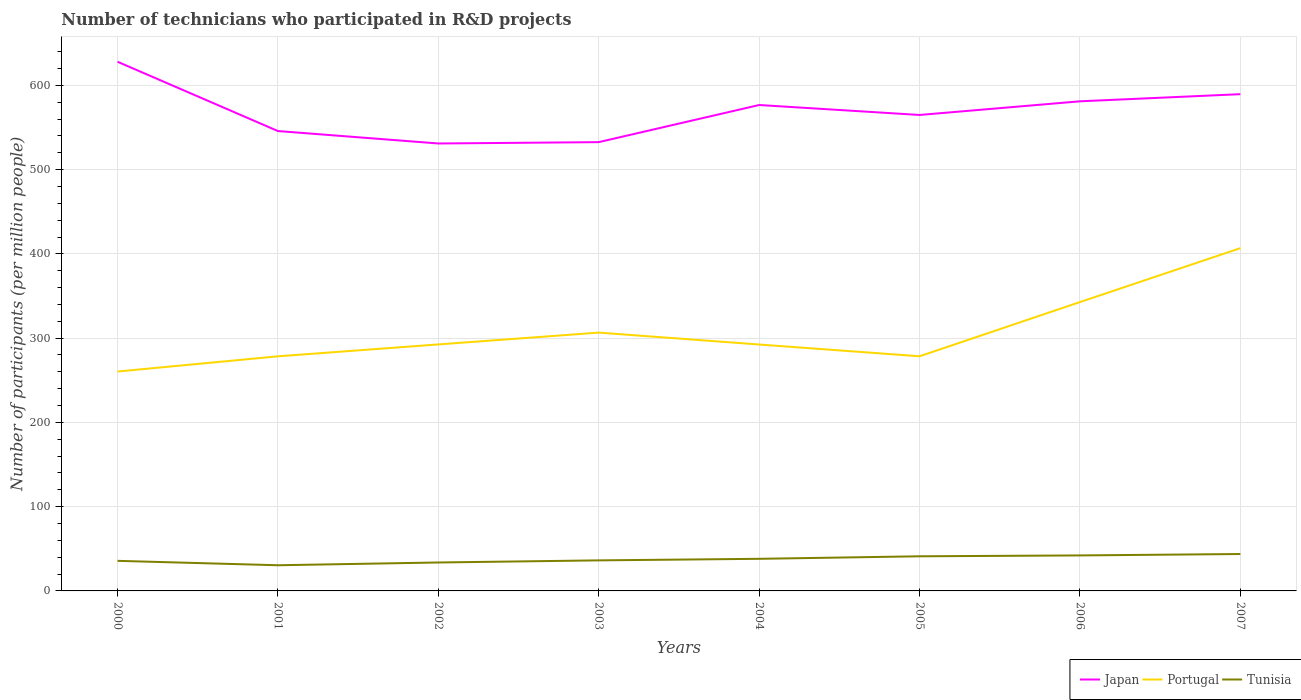Is the number of lines equal to the number of legend labels?
Make the answer very short. Yes. Across all years, what is the maximum number of technicians who participated in R&D projects in Portugal?
Make the answer very short. 260.36. In which year was the number of technicians who participated in R&D projects in Portugal maximum?
Provide a succinct answer. 2000. What is the total number of technicians who participated in R&D projects in Japan in the graph?
Your answer should be very brief. 14.77. What is the difference between the highest and the second highest number of technicians who participated in R&D projects in Tunisia?
Your response must be concise. 13.34. What is the difference between the highest and the lowest number of technicians who participated in R&D projects in Japan?
Give a very brief answer. 4. How many lines are there?
Provide a succinct answer. 3. How many years are there in the graph?
Provide a succinct answer. 8. Does the graph contain any zero values?
Give a very brief answer. No. How many legend labels are there?
Offer a very short reply. 3. What is the title of the graph?
Offer a terse response. Number of technicians who participated in R&D projects. Does "Tanzania" appear as one of the legend labels in the graph?
Give a very brief answer. No. What is the label or title of the Y-axis?
Ensure brevity in your answer.  Number of participants (per million people). What is the Number of participants (per million people) in Japan in 2000?
Your response must be concise. 628.02. What is the Number of participants (per million people) in Portugal in 2000?
Make the answer very short. 260.36. What is the Number of participants (per million people) of Tunisia in 2000?
Make the answer very short. 35.7. What is the Number of participants (per million people) of Japan in 2001?
Offer a very short reply. 545.78. What is the Number of participants (per million people) of Portugal in 2001?
Your answer should be very brief. 278.43. What is the Number of participants (per million people) of Tunisia in 2001?
Keep it short and to the point. 30.46. What is the Number of participants (per million people) of Japan in 2002?
Your response must be concise. 531.01. What is the Number of participants (per million people) of Portugal in 2002?
Give a very brief answer. 292.55. What is the Number of participants (per million people) of Tunisia in 2002?
Make the answer very short. 33.74. What is the Number of participants (per million people) in Japan in 2003?
Give a very brief answer. 532.62. What is the Number of participants (per million people) in Portugal in 2003?
Offer a terse response. 306.57. What is the Number of participants (per million people) of Tunisia in 2003?
Provide a short and direct response. 36.25. What is the Number of participants (per million people) in Japan in 2004?
Your response must be concise. 576.67. What is the Number of participants (per million people) of Portugal in 2004?
Give a very brief answer. 292.44. What is the Number of participants (per million people) of Tunisia in 2004?
Provide a succinct answer. 38.1. What is the Number of participants (per million people) in Japan in 2005?
Provide a succinct answer. 564.87. What is the Number of participants (per million people) in Portugal in 2005?
Your answer should be very brief. 278.47. What is the Number of participants (per million people) in Tunisia in 2005?
Keep it short and to the point. 41.09. What is the Number of participants (per million people) in Japan in 2006?
Ensure brevity in your answer.  581.06. What is the Number of participants (per million people) of Portugal in 2006?
Your answer should be very brief. 342.81. What is the Number of participants (per million people) in Tunisia in 2006?
Make the answer very short. 42.12. What is the Number of participants (per million people) of Japan in 2007?
Your answer should be very brief. 589.54. What is the Number of participants (per million people) in Portugal in 2007?
Offer a very short reply. 406.8. What is the Number of participants (per million people) of Tunisia in 2007?
Ensure brevity in your answer.  43.8. Across all years, what is the maximum Number of participants (per million people) in Japan?
Give a very brief answer. 628.02. Across all years, what is the maximum Number of participants (per million people) in Portugal?
Give a very brief answer. 406.8. Across all years, what is the maximum Number of participants (per million people) of Tunisia?
Offer a very short reply. 43.8. Across all years, what is the minimum Number of participants (per million people) of Japan?
Provide a short and direct response. 531.01. Across all years, what is the minimum Number of participants (per million people) of Portugal?
Offer a very short reply. 260.36. Across all years, what is the minimum Number of participants (per million people) of Tunisia?
Provide a short and direct response. 30.46. What is the total Number of participants (per million people) of Japan in the graph?
Your answer should be compact. 4549.56. What is the total Number of participants (per million people) of Portugal in the graph?
Ensure brevity in your answer.  2458.43. What is the total Number of participants (per million people) of Tunisia in the graph?
Your response must be concise. 301.27. What is the difference between the Number of participants (per million people) in Japan in 2000 and that in 2001?
Provide a short and direct response. 82.24. What is the difference between the Number of participants (per million people) in Portugal in 2000 and that in 2001?
Keep it short and to the point. -18.07. What is the difference between the Number of participants (per million people) in Tunisia in 2000 and that in 2001?
Your response must be concise. 5.24. What is the difference between the Number of participants (per million people) in Japan in 2000 and that in 2002?
Your response must be concise. 97.01. What is the difference between the Number of participants (per million people) of Portugal in 2000 and that in 2002?
Offer a very short reply. -32.19. What is the difference between the Number of participants (per million people) in Tunisia in 2000 and that in 2002?
Your response must be concise. 1.95. What is the difference between the Number of participants (per million people) in Japan in 2000 and that in 2003?
Your answer should be compact. 95.4. What is the difference between the Number of participants (per million people) in Portugal in 2000 and that in 2003?
Your answer should be compact. -46.21. What is the difference between the Number of participants (per million people) in Tunisia in 2000 and that in 2003?
Make the answer very short. -0.56. What is the difference between the Number of participants (per million people) of Japan in 2000 and that in 2004?
Ensure brevity in your answer.  51.35. What is the difference between the Number of participants (per million people) in Portugal in 2000 and that in 2004?
Ensure brevity in your answer.  -32.08. What is the difference between the Number of participants (per million people) of Tunisia in 2000 and that in 2004?
Your answer should be compact. -2.4. What is the difference between the Number of participants (per million people) in Japan in 2000 and that in 2005?
Offer a terse response. 63.15. What is the difference between the Number of participants (per million people) in Portugal in 2000 and that in 2005?
Offer a terse response. -18.11. What is the difference between the Number of participants (per million people) of Tunisia in 2000 and that in 2005?
Provide a succinct answer. -5.39. What is the difference between the Number of participants (per million people) of Japan in 2000 and that in 2006?
Ensure brevity in your answer.  46.96. What is the difference between the Number of participants (per million people) in Portugal in 2000 and that in 2006?
Give a very brief answer. -82.45. What is the difference between the Number of participants (per million people) of Tunisia in 2000 and that in 2006?
Your response must be concise. -6.43. What is the difference between the Number of participants (per million people) in Japan in 2000 and that in 2007?
Make the answer very short. 38.48. What is the difference between the Number of participants (per million people) of Portugal in 2000 and that in 2007?
Provide a short and direct response. -146.44. What is the difference between the Number of participants (per million people) of Tunisia in 2000 and that in 2007?
Your answer should be very brief. -8.1. What is the difference between the Number of participants (per million people) of Japan in 2001 and that in 2002?
Ensure brevity in your answer.  14.77. What is the difference between the Number of participants (per million people) in Portugal in 2001 and that in 2002?
Your response must be concise. -14.12. What is the difference between the Number of participants (per million people) of Tunisia in 2001 and that in 2002?
Provide a succinct answer. -3.29. What is the difference between the Number of participants (per million people) in Japan in 2001 and that in 2003?
Provide a short and direct response. 13.16. What is the difference between the Number of participants (per million people) in Portugal in 2001 and that in 2003?
Ensure brevity in your answer.  -28.14. What is the difference between the Number of participants (per million people) of Tunisia in 2001 and that in 2003?
Offer a very short reply. -5.79. What is the difference between the Number of participants (per million people) of Japan in 2001 and that in 2004?
Offer a terse response. -30.89. What is the difference between the Number of participants (per million people) in Portugal in 2001 and that in 2004?
Your response must be concise. -14.01. What is the difference between the Number of participants (per million people) of Tunisia in 2001 and that in 2004?
Ensure brevity in your answer.  -7.64. What is the difference between the Number of participants (per million people) in Japan in 2001 and that in 2005?
Ensure brevity in your answer.  -19.09. What is the difference between the Number of participants (per million people) of Portugal in 2001 and that in 2005?
Give a very brief answer. -0.04. What is the difference between the Number of participants (per million people) in Tunisia in 2001 and that in 2005?
Your answer should be very brief. -10.63. What is the difference between the Number of participants (per million people) of Japan in 2001 and that in 2006?
Your response must be concise. -35.28. What is the difference between the Number of participants (per million people) in Portugal in 2001 and that in 2006?
Offer a terse response. -64.38. What is the difference between the Number of participants (per million people) of Tunisia in 2001 and that in 2006?
Give a very brief answer. -11.67. What is the difference between the Number of participants (per million people) of Japan in 2001 and that in 2007?
Provide a succinct answer. -43.76. What is the difference between the Number of participants (per million people) in Portugal in 2001 and that in 2007?
Make the answer very short. -128.37. What is the difference between the Number of participants (per million people) of Tunisia in 2001 and that in 2007?
Give a very brief answer. -13.34. What is the difference between the Number of participants (per million people) of Japan in 2002 and that in 2003?
Offer a very short reply. -1.61. What is the difference between the Number of participants (per million people) in Portugal in 2002 and that in 2003?
Your answer should be compact. -14.03. What is the difference between the Number of participants (per million people) of Tunisia in 2002 and that in 2003?
Give a very brief answer. -2.51. What is the difference between the Number of participants (per million people) in Japan in 2002 and that in 2004?
Provide a succinct answer. -45.66. What is the difference between the Number of participants (per million people) in Portugal in 2002 and that in 2004?
Offer a very short reply. 0.1. What is the difference between the Number of participants (per million people) of Tunisia in 2002 and that in 2004?
Offer a very short reply. -4.36. What is the difference between the Number of participants (per million people) in Japan in 2002 and that in 2005?
Make the answer very short. -33.85. What is the difference between the Number of participants (per million people) of Portugal in 2002 and that in 2005?
Your answer should be very brief. 14.08. What is the difference between the Number of participants (per million people) of Tunisia in 2002 and that in 2005?
Keep it short and to the point. -7.34. What is the difference between the Number of participants (per million people) of Japan in 2002 and that in 2006?
Keep it short and to the point. -50.05. What is the difference between the Number of participants (per million people) of Portugal in 2002 and that in 2006?
Your answer should be compact. -50.27. What is the difference between the Number of participants (per million people) of Tunisia in 2002 and that in 2006?
Your answer should be compact. -8.38. What is the difference between the Number of participants (per million people) of Japan in 2002 and that in 2007?
Your answer should be very brief. -58.53. What is the difference between the Number of participants (per million people) of Portugal in 2002 and that in 2007?
Ensure brevity in your answer.  -114.26. What is the difference between the Number of participants (per million people) in Tunisia in 2002 and that in 2007?
Make the answer very short. -10.06. What is the difference between the Number of participants (per million people) in Japan in 2003 and that in 2004?
Make the answer very short. -44.05. What is the difference between the Number of participants (per million people) of Portugal in 2003 and that in 2004?
Your answer should be very brief. 14.13. What is the difference between the Number of participants (per million people) of Tunisia in 2003 and that in 2004?
Your answer should be very brief. -1.85. What is the difference between the Number of participants (per million people) in Japan in 2003 and that in 2005?
Ensure brevity in your answer.  -32.25. What is the difference between the Number of participants (per million people) in Portugal in 2003 and that in 2005?
Ensure brevity in your answer.  28.1. What is the difference between the Number of participants (per million people) in Tunisia in 2003 and that in 2005?
Your answer should be very brief. -4.84. What is the difference between the Number of participants (per million people) in Japan in 2003 and that in 2006?
Provide a short and direct response. -48.44. What is the difference between the Number of participants (per million people) in Portugal in 2003 and that in 2006?
Offer a terse response. -36.24. What is the difference between the Number of participants (per million people) of Tunisia in 2003 and that in 2006?
Your answer should be compact. -5.87. What is the difference between the Number of participants (per million people) of Japan in 2003 and that in 2007?
Your answer should be very brief. -56.92. What is the difference between the Number of participants (per million people) in Portugal in 2003 and that in 2007?
Your answer should be compact. -100.23. What is the difference between the Number of participants (per million people) in Tunisia in 2003 and that in 2007?
Give a very brief answer. -7.55. What is the difference between the Number of participants (per million people) of Japan in 2004 and that in 2005?
Your answer should be very brief. 11.8. What is the difference between the Number of participants (per million people) in Portugal in 2004 and that in 2005?
Offer a terse response. 13.97. What is the difference between the Number of participants (per million people) in Tunisia in 2004 and that in 2005?
Offer a very short reply. -2.99. What is the difference between the Number of participants (per million people) of Japan in 2004 and that in 2006?
Offer a terse response. -4.39. What is the difference between the Number of participants (per million people) in Portugal in 2004 and that in 2006?
Provide a succinct answer. -50.37. What is the difference between the Number of participants (per million people) in Tunisia in 2004 and that in 2006?
Provide a short and direct response. -4.02. What is the difference between the Number of participants (per million people) in Japan in 2004 and that in 2007?
Your response must be concise. -12.87. What is the difference between the Number of participants (per million people) of Portugal in 2004 and that in 2007?
Your answer should be very brief. -114.36. What is the difference between the Number of participants (per million people) of Tunisia in 2004 and that in 2007?
Offer a very short reply. -5.7. What is the difference between the Number of participants (per million people) of Japan in 2005 and that in 2006?
Ensure brevity in your answer.  -16.19. What is the difference between the Number of participants (per million people) of Portugal in 2005 and that in 2006?
Provide a short and direct response. -64.34. What is the difference between the Number of participants (per million people) of Tunisia in 2005 and that in 2006?
Offer a terse response. -1.04. What is the difference between the Number of participants (per million people) of Japan in 2005 and that in 2007?
Your answer should be very brief. -24.67. What is the difference between the Number of participants (per million people) in Portugal in 2005 and that in 2007?
Make the answer very short. -128.33. What is the difference between the Number of participants (per million people) of Tunisia in 2005 and that in 2007?
Provide a short and direct response. -2.71. What is the difference between the Number of participants (per million people) of Japan in 2006 and that in 2007?
Offer a very short reply. -8.48. What is the difference between the Number of participants (per million people) in Portugal in 2006 and that in 2007?
Give a very brief answer. -63.99. What is the difference between the Number of participants (per million people) in Tunisia in 2006 and that in 2007?
Keep it short and to the point. -1.68. What is the difference between the Number of participants (per million people) in Japan in 2000 and the Number of participants (per million people) in Portugal in 2001?
Keep it short and to the point. 349.59. What is the difference between the Number of participants (per million people) of Japan in 2000 and the Number of participants (per million people) of Tunisia in 2001?
Give a very brief answer. 597.56. What is the difference between the Number of participants (per million people) in Portugal in 2000 and the Number of participants (per million people) in Tunisia in 2001?
Your answer should be compact. 229.9. What is the difference between the Number of participants (per million people) in Japan in 2000 and the Number of participants (per million people) in Portugal in 2002?
Offer a very short reply. 335.47. What is the difference between the Number of participants (per million people) in Japan in 2000 and the Number of participants (per million people) in Tunisia in 2002?
Ensure brevity in your answer.  594.27. What is the difference between the Number of participants (per million people) in Portugal in 2000 and the Number of participants (per million people) in Tunisia in 2002?
Make the answer very short. 226.61. What is the difference between the Number of participants (per million people) in Japan in 2000 and the Number of participants (per million people) in Portugal in 2003?
Your answer should be compact. 321.45. What is the difference between the Number of participants (per million people) of Japan in 2000 and the Number of participants (per million people) of Tunisia in 2003?
Provide a succinct answer. 591.76. What is the difference between the Number of participants (per million people) of Portugal in 2000 and the Number of participants (per million people) of Tunisia in 2003?
Provide a succinct answer. 224.1. What is the difference between the Number of participants (per million people) of Japan in 2000 and the Number of participants (per million people) of Portugal in 2004?
Your response must be concise. 335.58. What is the difference between the Number of participants (per million people) of Japan in 2000 and the Number of participants (per million people) of Tunisia in 2004?
Offer a very short reply. 589.92. What is the difference between the Number of participants (per million people) of Portugal in 2000 and the Number of participants (per million people) of Tunisia in 2004?
Your answer should be very brief. 222.26. What is the difference between the Number of participants (per million people) in Japan in 2000 and the Number of participants (per million people) in Portugal in 2005?
Your answer should be very brief. 349.55. What is the difference between the Number of participants (per million people) in Japan in 2000 and the Number of participants (per million people) in Tunisia in 2005?
Make the answer very short. 586.93. What is the difference between the Number of participants (per million people) in Portugal in 2000 and the Number of participants (per million people) in Tunisia in 2005?
Provide a short and direct response. 219.27. What is the difference between the Number of participants (per million people) in Japan in 2000 and the Number of participants (per million people) in Portugal in 2006?
Keep it short and to the point. 285.2. What is the difference between the Number of participants (per million people) of Japan in 2000 and the Number of participants (per million people) of Tunisia in 2006?
Ensure brevity in your answer.  585.89. What is the difference between the Number of participants (per million people) of Portugal in 2000 and the Number of participants (per million people) of Tunisia in 2006?
Offer a very short reply. 218.23. What is the difference between the Number of participants (per million people) in Japan in 2000 and the Number of participants (per million people) in Portugal in 2007?
Provide a short and direct response. 221.22. What is the difference between the Number of participants (per million people) of Japan in 2000 and the Number of participants (per million people) of Tunisia in 2007?
Offer a very short reply. 584.22. What is the difference between the Number of participants (per million people) of Portugal in 2000 and the Number of participants (per million people) of Tunisia in 2007?
Ensure brevity in your answer.  216.56. What is the difference between the Number of participants (per million people) of Japan in 2001 and the Number of participants (per million people) of Portugal in 2002?
Offer a terse response. 253.23. What is the difference between the Number of participants (per million people) of Japan in 2001 and the Number of participants (per million people) of Tunisia in 2002?
Give a very brief answer. 512.03. What is the difference between the Number of participants (per million people) in Portugal in 2001 and the Number of participants (per million people) in Tunisia in 2002?
Your answer should be compact. 244.68. What is the difference between the Number of participants (per million people) in Japan in 2001 and the Number of participants (per million people) in Portugal in 2003?
Your response must be concise. 239.21. What is the difference between the Number of participants (per million people) of Japan in 2001 and the Number of participants (per million people) of Tunisia in 2003?
Keep it short and to the point. 509.52. What is the difference between the Number of participants (per million people) of Portugal in 2001 and the Number of participants (per million people) of Tunisia in 2003?
Offer a terse response. 242.18. What is the difference between the Number of participants (per million people) in Japan in 2001 and the Number of participants (per million people) in Portugal in 2004?
Provide a succinct answer. 253.34. What is the difference between the Number of participants (per million people) in Japan in 2001 and the Number of participants (per million people) in Tunisia in 2004?
Your answer should be very brief. 507.68. What is the difference between the Number of participants (per million people) in Portugal in 2001 and the Number of participants (per million people) in Tunisia in 2004?
Offer a very short reply. 240.33. What is the difference between the Number of participants (per million people) in Japan in 2001 and the Number of participants (per million people) in Portugal in 2005?
Offer a very short reply. 267.31. What is the difference between the Number of participants (per million people) in Japan in 2001 and the Number of participants (per million people) in Tunisia in 2005?
Provide a succinct answer. 504.69. What is the difference between the Number of participants (per million people) in Portugal in 2001 and the Number of participants (per million people) in Tunisia in 2005?
Your answer should be very brief. 237.34. What is the difference between the Number of participants (per million people) of Japan in 2001 and the Number of participants (per million people) of Portugal in 2006?
Your answer should be compact. 202.97. What is the difference between the Number of participants (per million people) in Japan in 2001 and the Number of participants (per million people) in Tunisia in 2006?
Make the answer very short. 503.65. What is the difference between the Number of participants (per million people) of Portugal in 2001 and the Number of participants (per million people) of Tunisia in 2006?
Provide a succinct answer. 236.3. What is the difference between the Number of participants (per million people) in Japan in 2001 and the Number of participants (per million people) in Portugal in 2007?
Your response must be concise. 138.98. What is the difference between the Number of participants (per million people) in Japan in 2001 and the Number of participants (per million people) in Tunisia in 2007?
Keep it short and to the point. 501.98. What is the difference between the Number of participants (per million people) in Portugal in 2001 and the Number of participants (per million people) in Tunisia in 2007?
Make the answer very short. 234.63. What is the difference between the Number of participants (per million people) in Japan in 2002 and the Number of participants (per million people) in Portugal in 2003?
Provide a short and direct response. 224.44. What is the difference between the Number of participants (per million people) of Japan in 2002 and the Number of participants (per million people) of Tunisia in 2003?
Ensure brevity in your answer.  494.76. What is the difference between the Number of participants (per million people) in Portugal in 2002 and the Number of participants (per million people) in Tunisia in 2003?
Your answer should be very brief. 256.29. What is the difference between the Number of participants (per million people) of Japan in 2002 and the Number of participants (per million people) of Portugal in 2004?
Offer a very short reply. 238.57. What is the difference between the Number of participants (per million people) in Japan in 2002 and the Number of participants (per million people) in Tunisia in 2004?
Your response must be concise. 492.91. What is the difference between the Number of participants (per million people) in Portugal in 2002 and the Number of participants (per million people) in Tunisia in 2004?
Your response must be concise. 254.44. What is the difference between the Number of participants (per million people) of Japan in 2002 and the Number of participants (per million people) of Portugal in 2005?
Your answer should be very brief. 252.54. What is the difference between the Number of participants (per million people) in Japan in 2002 and the Number of participants (per million people) in Tunisia in 2005?
Your response must be concise. 489.92. What is the difference between the Number of participants (per million people) in Portugal in 2002 and the Number of participants (per million people) in Tunisia in 2005?
Keep it short and to the point. 251.46. What is the difference between the Number of participants (per million people) of Japan in 2002 and the Number of participants (per million people) of Portugal in 2006?
Give a very brief answer. 188.2. What is the difference between the Number of participants (per million people) of Japan in 2002 and the Number of participants (per million people) of Tunisia in 2006?
Ensure brevity in your answer.  488.89. What is the difference between the Number of participants (per million people) in Portugal in 2002 and the Number of participants (per million people) in Tunisia in 2006?
Ensure brevity in your answer.  250.42. What is the difference between the Number of participants (per million people) in Japan in 2002 and the Number of participants (per million people) in Portugal in 2007?
Offer a terse response. 124.21. What is the difference between the Number of participants (per million people) of Japan in 2002 and the Number of participants (per million people) of Tunisia in 2007?
Give a very brief answer. 487.21. What is the difference between the Number of participants (per million people) in Portugal in 2002 and the Number of participants (per million people) in Tunisia in 2007?
Offer a terse response. 248.75. What is the difference between the Number of participants (per million people) of Japan in 2003 and the Number of participants (per million people) of Portugal in 2004?
Your answer should be compact. 240.18. What is the difference between the Number of participants (per million people) in Japan in 2003 and the Number of participants (per million people) in Tunisia in 2004?
Your answer should be very brief. 494.52. What is the difference between the Number of participants (per million people) of Portugal in 2003 and the Number of participants (per million people) of Tunisia in 2004?
Keep it short and to the point. 268.47. What is the difference between the Number of participants (per million people) of Japan in 2003 and the Number of participants (per million people) of Portugal in 2005?
Offer a very short reply. 254.15. What is the difference between the Number of participants (per million people) in Japan in 2003 and the Number of participants (per million people) in Tunisia in 2005?
Provide a short and direct response. 491.53. What is the difference between the Number of participants (per million people) in Portugal in 2003 and the Number of participants (per million people) in Tunisia in 2005?
Give a very brief answer. 265.48. What is the difference between the Number of participants (per million people) in Japan in 2003 and the Number of participants (per million people) in Portugal in 2006?
Provide a short and direct response. 189.81. What is the difference between the Number of participants (per million people) in Japan in 2003 and the Number of participants (per million people) in Tunisia in 2006?
Keep it short and to the point. 490.49. What is the difference between the Number of participants (per million people) in Portugal in 2003 and the Number of participants (per million people) in Tunisia in 2006?
Your answer should be compact. 264.45. What is the difference between the Number of participants (per million people) in Japan in 2003 and the Number of participants (per million people) in Portugal in 2007?
Ensure brevity in your answer.  125.82. What is the difference between the Number of participants (per million people) in Japan in 2003 and the Number of participants (per million people) in Tunisia in 2007?
Keep it short and to the point. 488.82. What is the difference between the Number of participants (per million people) in Portugal in 2003 and the Number of participants (per million people) in Tunisia in 2007?
Provide a short and direct response. 262.77. What is the difference between the Number of participants (per million people) in Japan in 2004 and the Number of participants (per million people) in Portugal in 2005?
Provide a succinct answer. 298.2. What is the difference between the Number of participants (per million people) in Japan in 2004 and the Number of participants (per million people) in Tunisia in 2005?
Offer a terse response. 535.58. What is the difference between the Number of participants (per million people) in Portugal in 2004 and the Number of participants (per million people) in Tunisia in 2005?
Provide a succinct answer. 251.35. What is the difference between the Number of participants (per million people) of Japan in 2004 and the Number of participants (per million people) of Portugal in 2006?
Your answer should be very brief. 233.86. What is the difference between the Number of participants (per million people) in Japan in 2004 and the Number of participants (per million people) in Tunisia in 2006?
Provide a short and direct response. 534.54. What is the difference between the Number of participants (per million people) of Portugal in 2004 and the Number of participants (per million people) of Tunisia in 2006?
Keep it short and to the point. 250.32. What is the difference between the Number of participants (per million people) in Japan in 2004 and the Number of participants (per million people) in Portugal in 2007?
Provide a succinct answer. 169.87. What is the difference between the Number of participants (per million people) in Japan in 2004 and the Number of participants (per million people) in Tunisia in 2007?
Make the answer very short. 532.87. What is the difference between the Number of participants (per million people) of Portugal in 2004 and the Number of participants (per million people) of Tunisia in 2007?
Keep it short and to the point. 248.64. What is the difference between the Number of participants (per million people) in Japan in 2005 and the Number of participants (per million people) in Portugal in 2006?
Your answer should be very brief. 222.05. What is the difference between the Number of participants (per million people) in Japan in 2005 and the Number of participants (per million people) in Tunisia in 2006?
Your answer should be very brief. 522.74. What is the difference between the Number of participants (per million people) of Portugal in 2005 and the Number of participants (per million people) of Tunisia in 2006?
Make the answer very short. 236.34. What is the difference between the Number of participants (per million people) of Japan in 2005 and the Number of participants (per million people) of Portugal in 2007?
Provide a short and direct response. 158.06. What is the difference between the Number of participants (per million people) of Japan in 2005 and the Number of participants (per million people) of Tunisia in 2007?
Your answer should be compact. 521.07. What is the difference between the Number of participants (per million people) in Portugal in 2005 and the Number of participants (per million people) in Tunisia in 2007?
Offer a very short reply. 234.67. What is the difference between the Number of participants (per million people) in Japan in 2006 and the Number of participants (per million people) in Portugal in 2007?
Your answer should be very brief. 174.26. What is the difference between the Number of participants (per million people) of Japan in 2006 and the Number of participants (per million people) of Tunisia in 2007?
Your answer should be compact. 537.26. What is the difference between the Number of participants (per million people) of Portugal in 2006 and the Number of participants (per million people) of Tunisia in 2007?
Keep it short and to the point. 299.01. What is the average Number of participants (per million people) of Japan per year?
Offer a very short reply. 568.7. What is the average Number of participants (per million people) of Portugal per year?
Make the answer very short. 307.3. What is the average Number of participants (per million people) of Tunisia per year?
Offer a terse response. 37.66. In the year 2000, what is the difference between the Number of participants (per million people) in Japan and Number of participants (per million people) in Portugal?
Provide a short and direct response. 367.66. In the year 2000, what is the difference between the Number of participants (per million people) in Japan and Number of participants (per million people) in Tunisia?
Provide a succinct answer. 592.32. In the year 2000, what is the difference between the Number of participants (per million people) in Portugal and Number of participants (per million people) in Tunisia?
Keep it short and to the point. 224.66. In the year 2001, what is the difference between the Number of participants (per million people) of Japan and Number of participants (per million people) of Portugal?
Make the answer very short. 267.35. In the year 2001, what is the difference between the Number of participants (per million people) of Japan and Number of participants (per million people) of Tunisia?
Offer a very short reply. 515.32. In the year 2001, what is the difference between the Number of participants (per million people) of Portugal and Number of participants (per million people) of Tunisia?
Give a very brief answer. 247.97. In the year 2002, what is the difference between the Number of participants (per million people) in Japan and Number of participants (per million people) in Portugal?
Your answer should be compact. 238.47. In the year 2002, what is the difference between the Number of participants (per million people) in Japan and Number of participants (per million people) in Tunisia?
Offer a terse response. 497.27. In the year 2002, what is the difference between the Number of participants (per million people) of Portugal and Number of participants (per million people) of Tunisia?
Make the answer very short. 258.8. In the year 2003, what is the difference between the Number of participants (per million people) of Japan and Number of participants (per million people) of Portugal?
Your response must be concise. 226.05. In the year 2003, what is the difference between the Number of participants (per million people) of Japan and Number of participants (per million people) of Tunisia?
Ensure brevity in your answer.  496.37. In the year 2003, what is the difference between the Number of participants (per million people) of Portugal and Number of participants (per million people) of Tunisia?
Provide a short and direct response. 270.32. In the year 2004, what is the difference between the Number of participants (per million people) in Japan and Number of participants (per million people) in Portugal?
Offer a terse response. 284.23. In the year 2004, what is the difference between the Number of participants (per million people) of Japan and Number of participants (per million people) of Tunisia?
Your answer should be compact. 538.57. In the year 2004, what is the difference between the Number of participants (per million people) of Portugal and Number of participants (per million people) of Tunisia?
Your response must be concise. 254.34. In the year 2005, what is the difference between the Number of participants (per million people) of Japan and Number of participants (per million people) of Portugal?
Give a very brief answer. 286.4. In the year 2005, what is the difference between the Number of participants (per million people) in Japan and Number of participants (per million people) in Tunisia?
Your answer should be very brief. 523.78. In the year 2005, what is the difference between the Number of participants (per million people) of Portugal and Number of participants (per million people) of Tunisia?
Give a very brief answer. 237.38. In the year 2006, what is the difference between the Number of participants (per million people) in Japan and Number of participants (per million people) in Portugal?
Make the answer very short. 238.25. In the year 2006, what is the difference between the Number of participants (per million people) in Japan and Number of participants (per million people) in Tunisia?
Your answer should be very brief. 538.94. In the year 2006, what is the difference between the Number of participants (per million people) of Portugal and Number of participants (per million people) of Tunisia?
Your answer should be very brief. 300.69. In the year 2007, what is the difference between the Number of participants (per million people) of Japan and Number of participants (per million people) of Portugal?
Offer a terse response. 182.74. In the year 2007, what is the difference between the Number of participants (per million people) in Japan and Number of participants (per million people) in Tunisia?
Offer a terse response. 545.74. In the year 2007, what is the difference between the Number of participants (per million people) in Portugal and Number of participants (per million people) in Tunisia?
Ensure brevity in your answer.  363. What is the ratio of the Number of participants (per million people) in Japan in 2000 to that in 2001?
Ensure brevity in your answer.  1.15. What is the ratio of the Number of participants (per million people) in Portugal in 2000 to that in 2001?
Keep it short and to the point. 0.94. What is the ratio of the Number of participants (per million people) of Tunisia in 2000 to that in 2001?
Keep it short and to the point. 1.17. What is the ratio of the Number of participants (per million people) of Japan in 2000 to that in 2002?
Your answer should be very brief. 1.18. What is the ratio of the Number of participants (per million people) in Portugal in 2000 to that in 2002?
Make the answer very short. 0.89. What is the ratio of the Number of participants (per million people) in Tunisia in 2000 to that in 2002?
Provide a short and direct response. 1.06. What is the ratio of the Number of participants (per million people) in Japan in 2000 to that in 2003?
Your answer should be compact. 1.18. What is the ratio of the Number of participants (per million people) in Portugal in 2000 to that in 2003?
Your answer should be compact. 0.85. What is the ratio of the Number of participants (per million people) of Tunisia in 2000 to that in 2003?
Your answer should be very brief. 0.98. What is the ratio of the Number of participants (per million people) in Japan in 2000 to that in 2004?
Your answer should be very brief. 1.09. What is the ratio of the Number of participants (per million people) of Portugal in 2000 to that in 2004?
Make the answer very short. 0.89. What is the ratio of the Number of participants (per million people) of Tunisia in 2000 to that in 2004?
Keep it short and to the point. 0.94. What is the ratio of the Number of participants (per million people) of Japan in 2000 to that in 2005?
Your response must be concise. 1.11. What is the ratio of the Number of participants (per million people) of Portugal in 2000 to that in 2005?
Your answer should be compact. 0.94. What is the ratio of the Number of participants (per million people) in Tunisia in 2000 to that in 2005?
Ensure brevity in your answer.  0.87. What is the ratio of the Number of participants (per million people) of Japan in 2000 to that in 2006?
Your answer should be very brief. 1.08. What is the ratio of the Number of participants (per million people) in Portugal in 2000 to that in 2006?
Provide a short and direct response. 0.76. What is the ratio of the Number of participants (per million people) in Tunisia in 2000 to that in 2006?
Ensure brevity in your answer.  0.85. What is the ratio of the Number of participants (per million people) in Japan in 2000 to that in 2007?
Provide a short and direct response. 1.07. What is the ratio of the Number of participants (per million people) of Portugal in 2000 to that in 2007?
Your answer should be compact. 0.64. What is the ratio of the Number of participants (per million people) in Tunisia in 2000 to that in 2007?
Offer a very short reply. 0.81. What is the ratio of the Number of participants (per million people) in Japan in 2001 to that in 2002?
Provide a short and direct response. 1.03. What is the ratio of the Number of participants (per million people) of Portugal in 2001 to that in 2002?
Offer a very short reply. 0.95. What is the ratio of the Number of participants (per million people) in Tunisia in 2001 to that in 2002?
Your response must be concise. 0.9. What is the ratio of the Number of participants (per million people) in Japan in 2001 to that in 2003?
Make the answer very short. 1.02. What is the ratio of the Number of participants (per million people) of Portugal in 2001 to that in 2003?
Keep it short and to the point. 0.91. What is the ratio of the Number of participants (per million people) in Tunisia in 2001 to that in 2003?
Keep it short and to the point. 0.84. What is the ratio of the Number of participants (per million people) of Japan in 2001 to that in 2004?
Your answer should be compact. 0.95. What is the ratio of the Number of participants (per million people) in Portugal in 2001 to that in 2004?
Give a very brief answer. 0.95. What is the ratio of the Number of participants (per million people) of Tunisia in 2001 to that in 2004?
Give a very brief answer. 0.8. What is the ratio of the Number of participants (per million people) of Japan in 2001 to that in 2005?
Give a very brief answer. 0.97. What is the ratio of the Number of participants (per million people) of Tunisia in 2001 to that in 2005?
Provide a succinct answer. 0.74. What is the ratio of the Number of participants (per million people) of Japan in 2001 to that in 2006?
Ensure brevity in your answer.  0.94. What is the ratio of the Number of participants (per million people) of Portugal in 2001 to that in 2006?
Your response must be concise. 0.81. What is the ratio of the Number of participants (per million people) in Tunisia in 2001 to that in 2006?
Offer a terse response. 0.72. What is the ratio of the Number of participants (per million people) of Japan in 2001 to that in 2007?
Make the answer very short. 0.93. What is the ratio of the Number of participants (per million people) in Portugal in 2001 to that in 2007?
Your response must be concise. 0.68. What is the ratio of the Number of participants (per million people) in Tunisia in 2001 to that in 2007?
Keep it short and to the point. 0.7. What is the ratio of the Number of participants (per million people) in Japan in 2002 to that in 2003?
Your response must be concise. 1. What is the ratio of the Number of participants (per million people) in Portugal in 2002 to that in 2003?
Ensure brevity in your answer.  0.95. What is the ratio of the Number of participants (per million people) of Tunisia in 2002 to that in 2003?
Offer a very short reply. 0.93. What is the ratio of the Number of participants (per million people) in Japan in 2002 to that in 2004?
Ensure brevity in your answer.  0.92. What is the ratio of the Number of participants (per million people) of Tunisia in 2002 to that in 2004?
Offer a terse response. 0.89. What is the ratio of the Number of participants (per million people) of Japan in 2002 to that in 2005?
Offer a terse response. 0.94. What is the ratio of the Number of participants (per million people) of Portugal in 2002 to that in 2005?
Provide a short and direct response. 1.05. What is the ratio of the Number of participants (per million people) of Tunisia in 2002 to that in 2005?
Provide a short and direct response. 0.82. What is the ratio of the Number of participants (per million people) in Japan in 2002 to that in 2006?
Your answer should be compact. 0.91. What is the ratio of the Number of participants (per million people) in Portugal in 2002 to that in 2006?
Provide a succinct answer. 0.85. What is the ratio of the Number of participants (per million people) of Tunisia in 2002 to that in 2006?
Make the answer very short. 0.8. What is the ratio of the Number of participants (per million people) of Japan in 2002 to that in 2007?
Ensure brevity in your answer.  0.9. What is the ratio of the Number of participants (per million people) of Portugal in 2002 to that in 2007?
Your answer should be very brief. 0.72. What is the ratio of the Number of participants (per million people) in Tunisia in 2002 to that in 2007?
Offer a very short reply. 0.77. What is the ratio of the Number of participants (per million people) of Japan in 2003 to that in 2004?
Your answer should be compact. 0.92. What is the ratio of the Number of participants (per million people) in Portugal in 2003 to that in 2004?
Keep it short and to the point. 1.05. What is the ratio of the Number of participants (per million people) in Tunisia in 2003 to that in 2004?
Offer a very short reply. 0.95. What is the ratio of the Number of participants (per million people) in Japan in 2003 to that in 2005?
Provide a short and direct response. 0.94. What is the ratio of the Number of participants (per million people) in Portugal in 2003 to that in 2005?
Provide a succinct answer. 1.1. What is the ratio of the Number of participants (per million people) in Tunisia in 2003 to that in 2005?
Offer a terse response. 0.88. What is the ratio of the Number of participants (per million people) in Japan in 2003 to that in 2006?
Offer a very short reply. 0.92. What is the ratio of the Number of participants (per million people) in Portugal in 2003 to that in 2006?
Provide a short and direct response. 0.89. What is the ratio of the Number of participants (per million people) in Tunisia in 2003 to that in 2006?
Offer a terse response. 0.86. What is the ratio of the Number of participants (per million people) of Japan in 2003 to that in 2007?
Keep it short and to the point. 0.9. What is the ratio of the Number of participants (per million people) of Portugal in 2003 to that in 2007?
Provide a short and direct response. 0.75. What is the ratio of the Number of participants (per million people) in Tunisia in 2003 to that in 2007?
Offer a terse response. 0.83. What is the ratio of the Number of participants (per million people) in Japan in 2004 to that in 2005?
Your answer should be compact. 1.02. What is the ratio of the Number of participants (per million people) of Portugal in 2004 to that in 2005?
Ensure brevity in your answer.  1.05. What is the ratio of the Number of participants (per million people) of Tunisia in 2004 to that in 2005?
Your response must be concise. 0.93. What is the ratio of the Number of participants (per million people) in Portugal in 2004 to that in 2006?
Make the answer very short. 0.85. What is the ratio of the Number of participants (per million people) of Tunisia in 2004 to that in 2006?
Make the answer very short. 0.9. What is the ratio of the Number of participants (per million people) of Japan in 2004 to that in 2007?
Your answer should be very brief. 0.98. What is the ratio of the Number of participants (per million people) in Portugal in 2004 to that in 2007?
Give a very brief answer. 0.72. What is the ratio of the Number of participants (per million people) in Tunisia in 2004 to that in 2007?
Give a very brief answer. 0.87. What is the ratio of the Number of participants (per million people) in Japan in 2005 to that in 2006?
Ensure brevity in your answer.  0.97. What is the ratio of the Number of participants (per million people) in Portugal in 2005 to that in 2006?
Your answer should be compact. 0.81. What is the ratio of the Number of participants (per million people) of Tunisia in 2005 to that in 2006?
Offer a terse response. 0.98. What is the ratio of the Number of participants (per million people) of Japan in 2005 to that in 2007?
Make the answer very short. 0.96. What is the ratio of the Number of participants (per million people) in Portugal in 2005 to that in 2007?
Give a very brief answer. 0.68. What is the ratio of the Number of participants (per million people) of Tunisia in 2005 to that in 2007?
Give a very brief answer. 0.94. What is the ratio of the Number of participants (per million people) of Japan in 2006 to that in 2007?
Offer a terse response. 0.99. What is the ratio of the Number of participants (per million people) in Portugal in 2006 to that in 2007?
Make the answer very short. 0.84. What is the ratio of the Number of participants (per million people) in Tunisia in 2006 to that in 2007?
Offer a terse response. 0.96. What is the difference between the highest and the second highest Number of participants (per million people) in Japan?
Your response must be concise. 38.48. What is the difference between the highest and the second highest Number of participants (per million people) in Portugal?
Offer a terse response. 63.99. What is the difference between the highest and the second highest Number of participants (per million people) in Tunisia?
Provide a short and direct response. 1.68. What is the difference between the highest and the lowest Number of participants (per million people) of Japan?
Offer a terse response. 97.01. What is the difference between the highest and the lowest Number of participants (per million people) of Portugal?
Provide a succinct answer. 146.44. What is the difference between the highest and the lowest Number of participants (per million people) of Tunisia?
Ensure brevity in your answer.  13.34. 